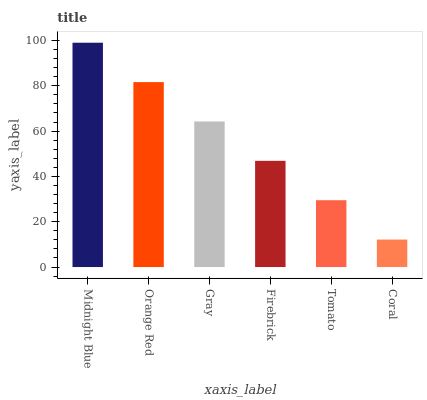Is Coral the minimum?
Answer yes or no. Yes. Is Midnight Blue the maximum?
Answer yes or no. Yes. Is Orange Red the minimum?
Answer yes or no. No. Is Orange Red the maximum?
Answer yes or no. No. Is Midnight Blue greater than Orange Red?
Answer yes or no. Yes. Is Orange Red less than Midnight Blue?
Answer yes or no. Yes. Is Orange Red greater than Midnight Blue?
Answer yes or no. No. Is Midnight Blue less than Orange Red?
Answer yes or no. No. Is Gray the high median?
Answer yes or no. Yes. Is Firebrick the low median?
Answer yes or no. Yes. Is Firebrick the high median?
Answer yes or no. No. Is Orange Red the low median?
Answer yes or no. No. 